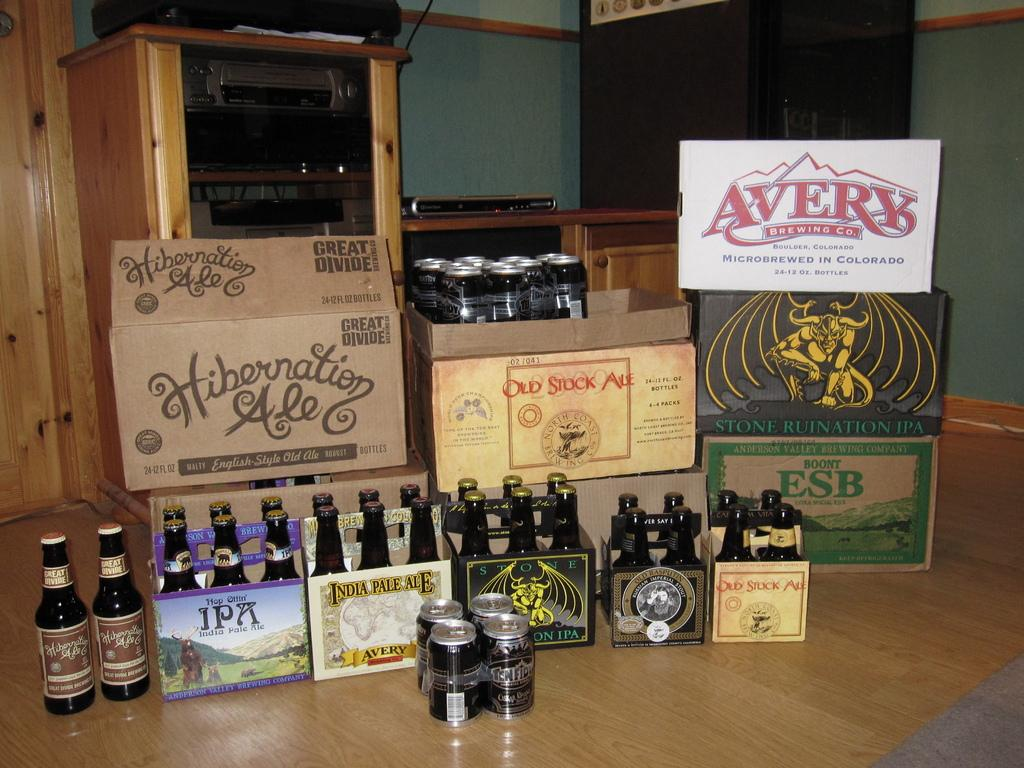Provide a one-sentence caption for the provided image. A box of Hibernation Ale sits with some other boxes of beer and six packs. 